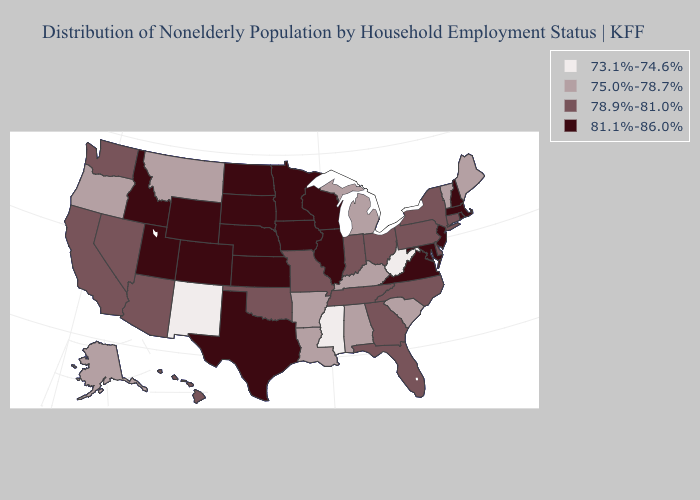What is the value of Texas?
Short answer required. 81.1%-86.0%. Does the map have missing data?
Be succinct. No. Does Maine have the highest value in the Northeast?
Give a very brief answer. No. Name the states that have a value in the range 73.1%-74.6%?
Keep it brief. Mississippi, New Mexico, West Virginia. Which states have the highest value in the USA?
Write a very short answer. Colorado, Idaho, Illinois, Iowa, Kansas, Maryland, Massachusetts, Minnesota, Nebraska, New Hampshire, New Jersey, North Dakota, Rhode Island, South Dakota, Texas, Utah, Virginia, Wisconsin, Wyoming. What is the value of Arizona?
Quick response, please. 78.9%-81.0%. Among the states that border California , does Nevada have the highest value?
Quick response, please. Yes. What is the lowest value in states that border Illinois?
Answer briefly. 75.0%-78.7%. Name the states that have a value in the range 75.0%-78.7%?
Be succinct. Alabama, Alaska, Arkansas, Kentucky, Louisiana, Maine, Michigan, Montana, Oregon, South Carolina, Vermont. Name the states that have a value in the range 81.1%-86.0%?
Be succinct. Colorado, Idaho, Illinois, Iowa, Kansas, Maryland, Massachusetts, Minnesota, Nebraska, New Hampshire, New Jersey, North Dakota, Rhode Island, South Dakota, Texas, Utah, Virginia, Wisconsin, Wyoming. What is the value of Kentucky?
Answer briefly. 75.0%-78.7%. What is the value of New York?
Keep it brief. 78.9%-81.0%. Name the states that have a value in the range 75.0%-78.7%?
Short answer required. Alabama, Alaska, Arkansas, Kentucky, Louisiana, Maine, Michigan, Montana, Oregon, South Carolina, Vermont. What is the highest value in the USA?
Write a very short answer. 81.1%-86.0%. Does Arizona have the same value as South Carolina?
Be succinct. No. 